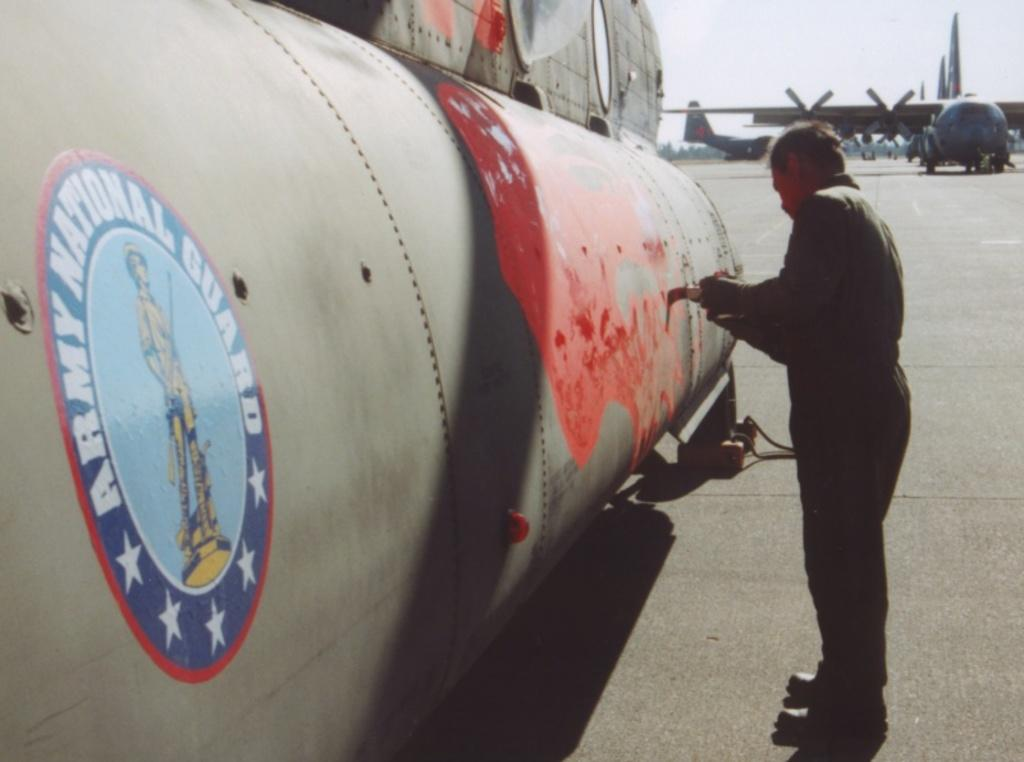<image>
Summarize the visual content of the image. A massive airplane has an Army National Guard sticker on its body. 